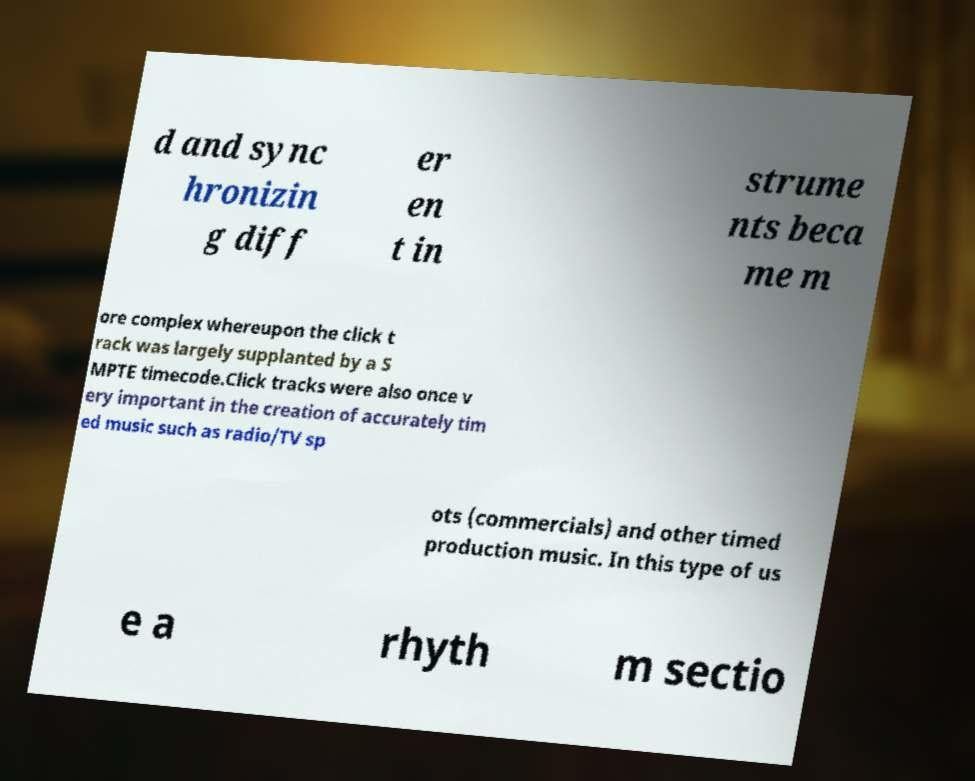Can you accurately transcribe the text from the provided image for me? d and sync hronizin g diff er en t in strume nts beca me m ore complex whereupon the click t rack was largely supplanted by a S MPTE timecode.Click tracks were also once v ery important in the creation of accurately tim ed music such as radio/TV sp ots (commercials) and other timed production music. In this type of us e a rhyth m sectio 